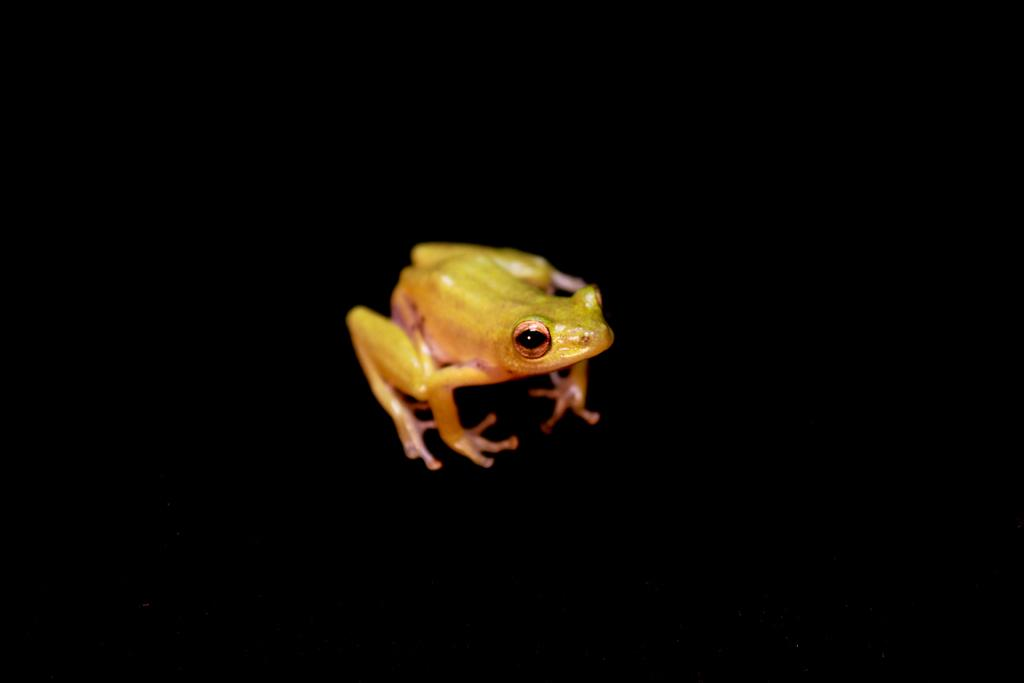What animal is present in the image? There is a frog in the image. What can be observed about the background of the image? The background of the image is dark. What is the condition of the kittens in the image? There are no kittens present in the image; it features a frog. How does the frog's growth appear in the image? The image does not provide information about the frog's growth, as it only shows the frog and the dark background. 